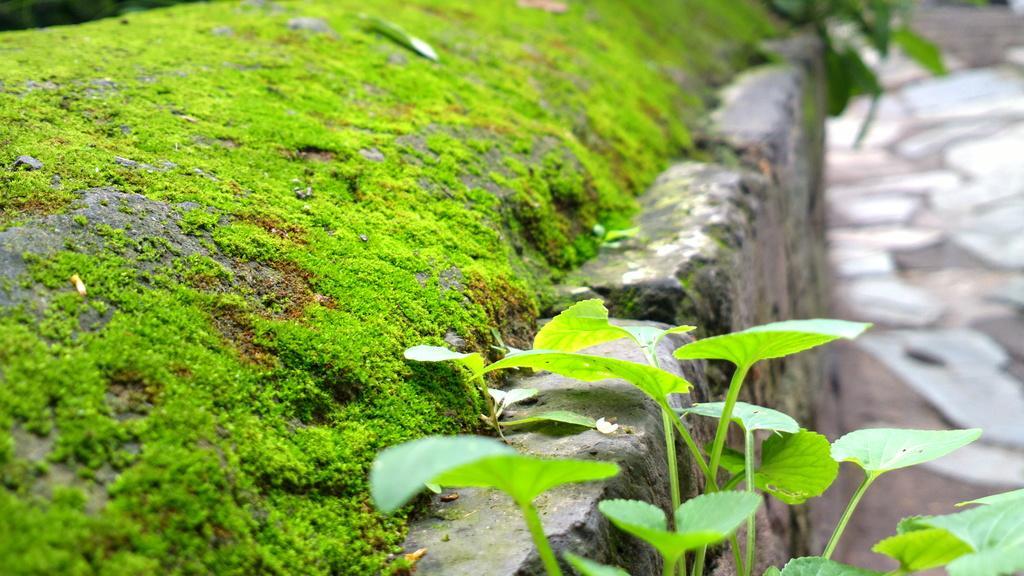How would you summarize this image in a sentence or two? In the foreground of the picture there are plants, wall, grass and soil. The background is blurred. 